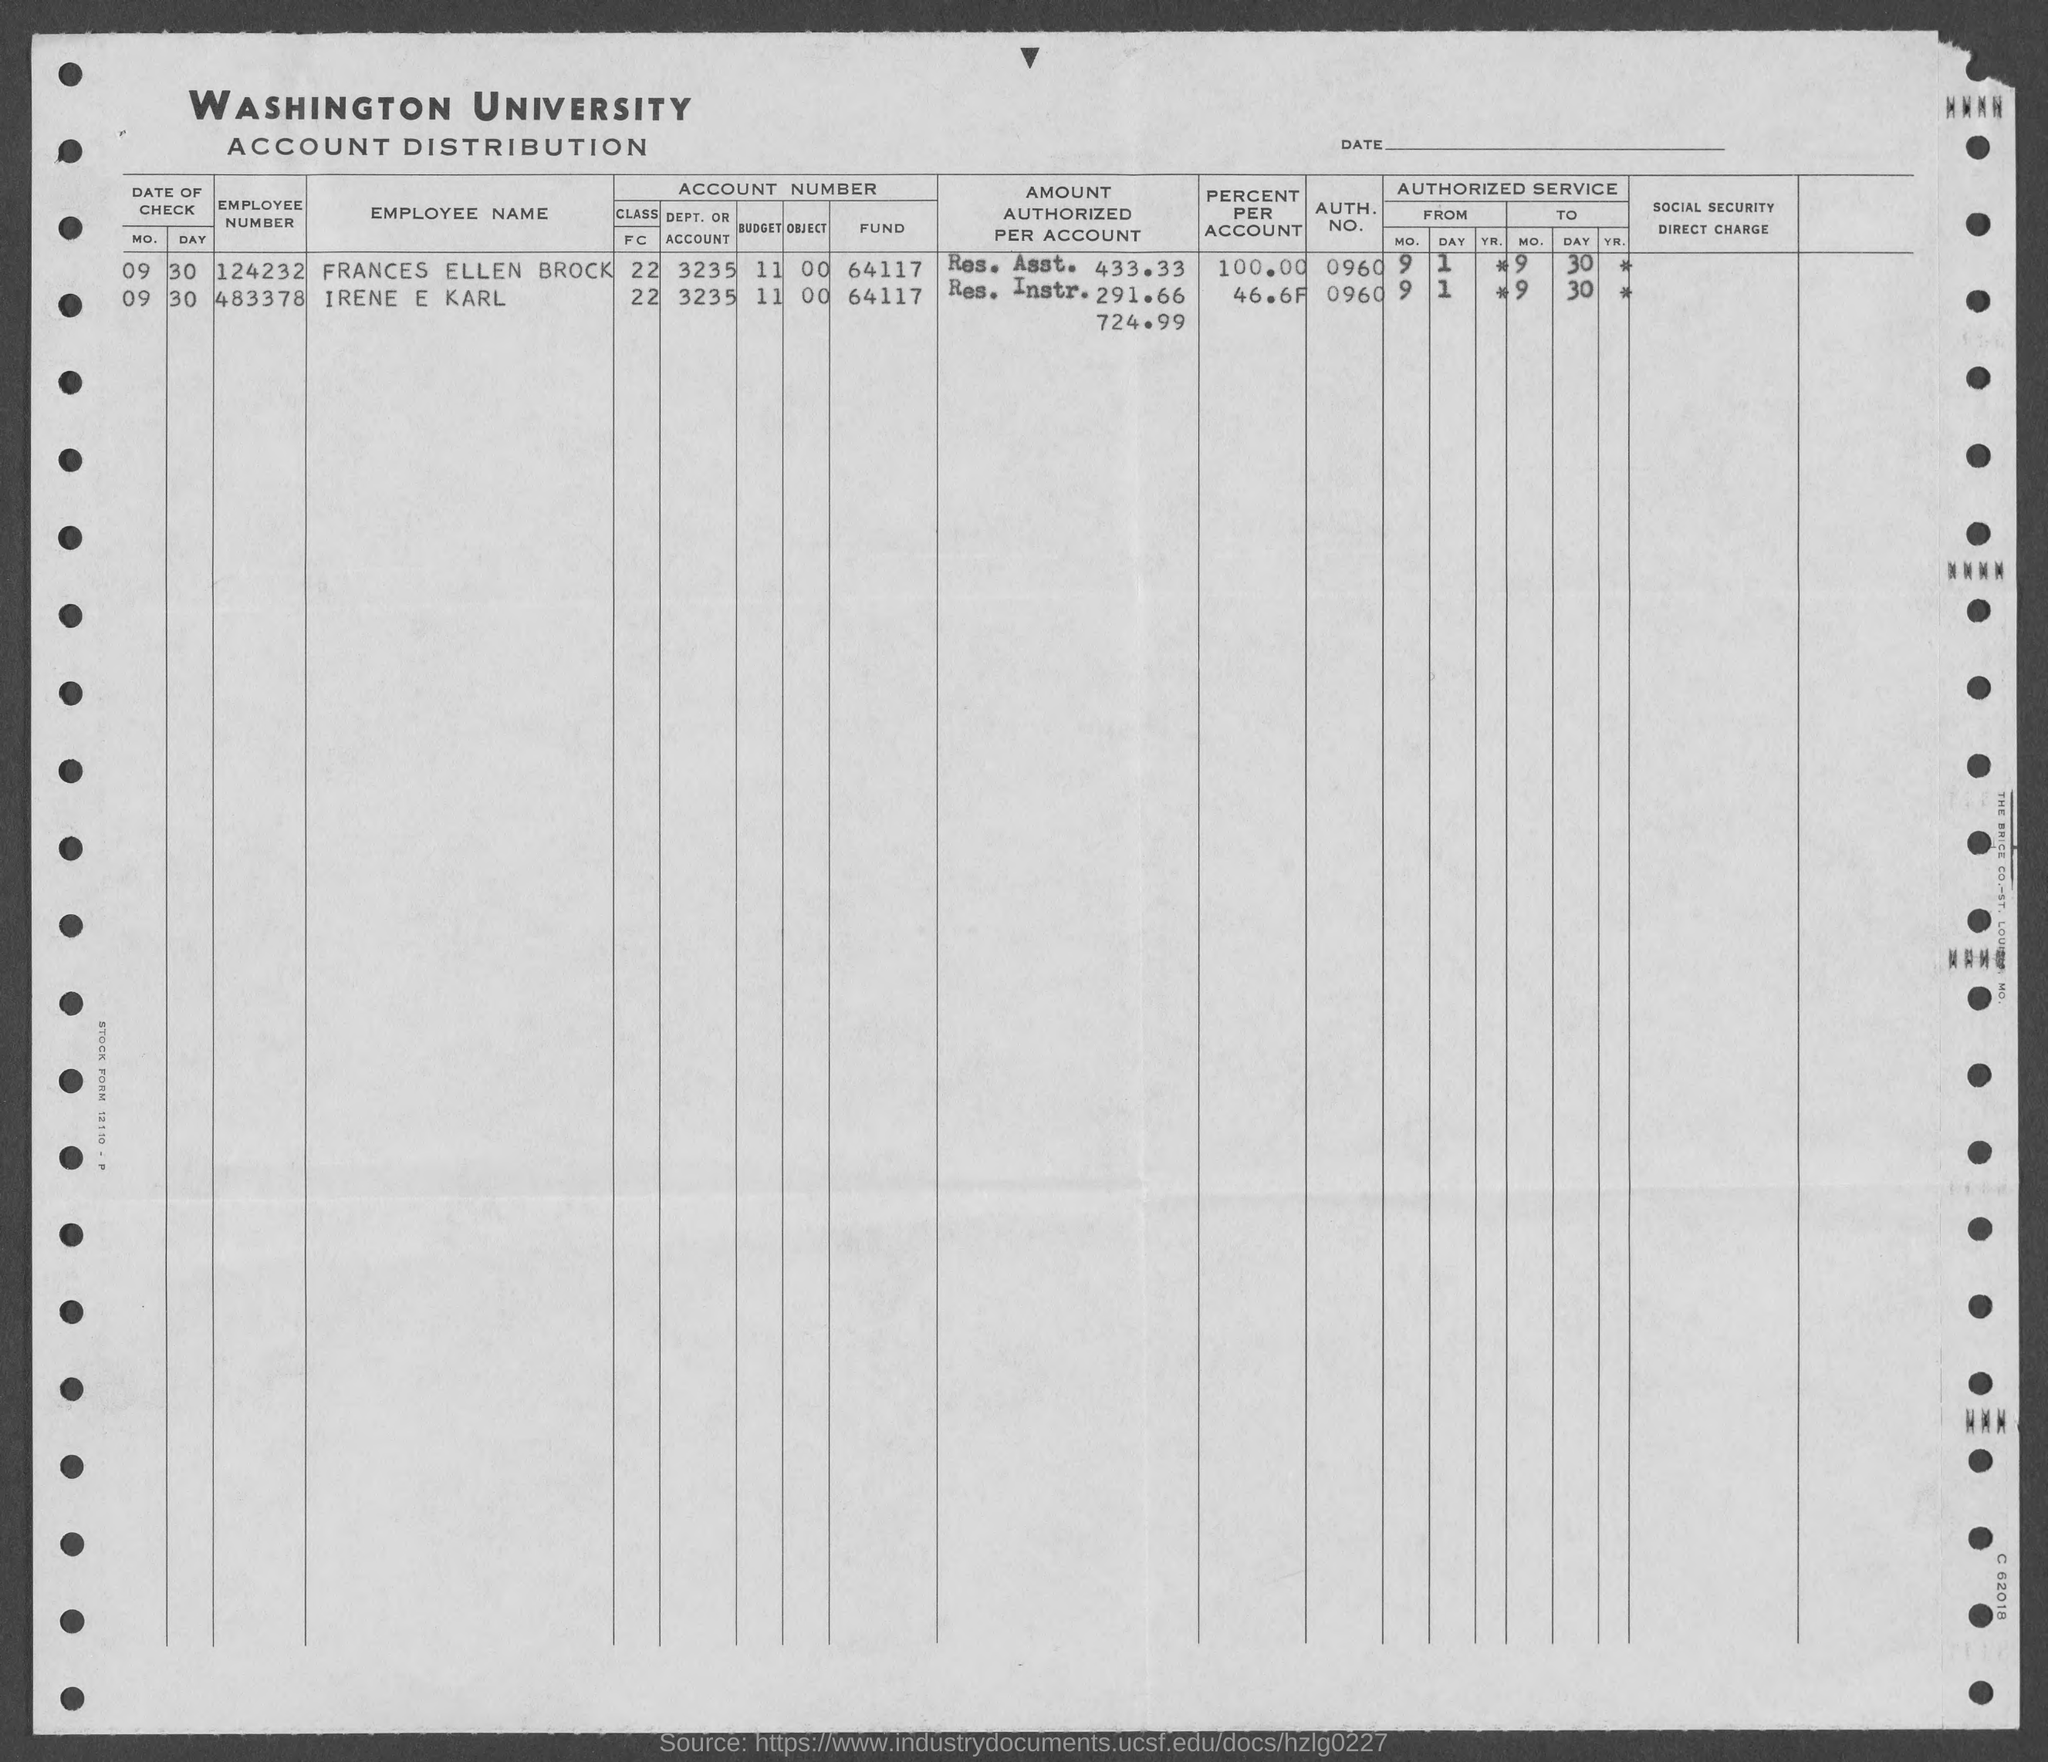Identify some key points in this picture. The authorization number of Frances Ellen Brock is 0960. The employment number for Irene E Karl is 483378. The employment number of Frances Ellen Brock is 124232. Irene E. Karl's authorization number is 0960. 